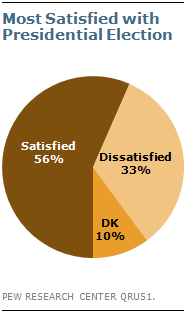Identify some key points in this picture. The dissatisfied percentage is 0.33. According to the study, if 500 people were asked whether they were satisfied, approximately 280 of them would answer "yes. 